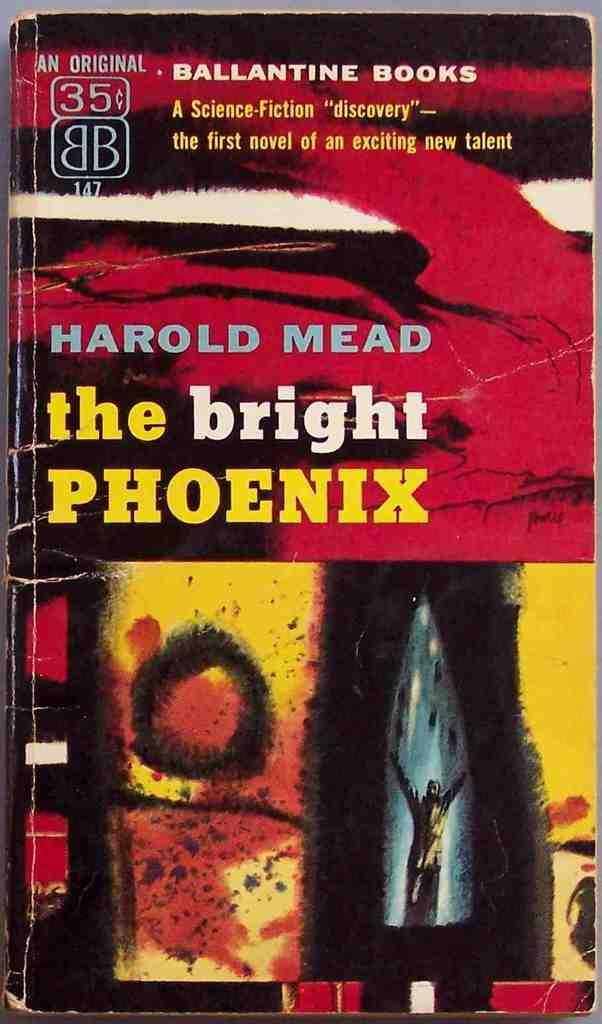What is the main subject of the image? The main subject of the image is a book cover page. What can be seen on the book cover page? There is writing on the book cover page. What type of bushes can be seen growing on the road in the image? There are no bushes or roads present in the image; it features a book cover page with writing on it. 